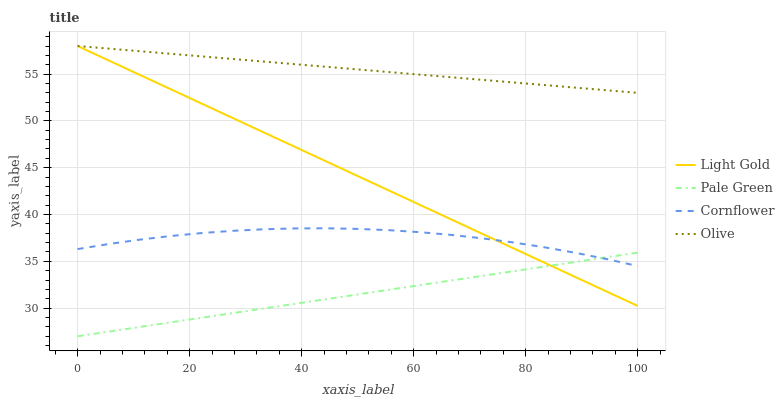Does Cornflower have the minimum area under the curve?
Answer yes or no. No. Does Cornflower have the maximum area under the curve?
Answer yes or no. No. Is Pale Green the smoothest?
Answer yes or no. No. Is Pale Green the roughest?
Answer yes or no. No. Does Cornflower have the lowest value?
Answer yes or no. No. Does Cornflower have the highest value?
Answer yes or no. No. Is Cornflower less than Olive?
Answer yes or no. Yes. Is Olive greater than Pale Green?
Answer yes or no. Yes. Does Cornflower intersect Olive?
Answer yes or no. No. 